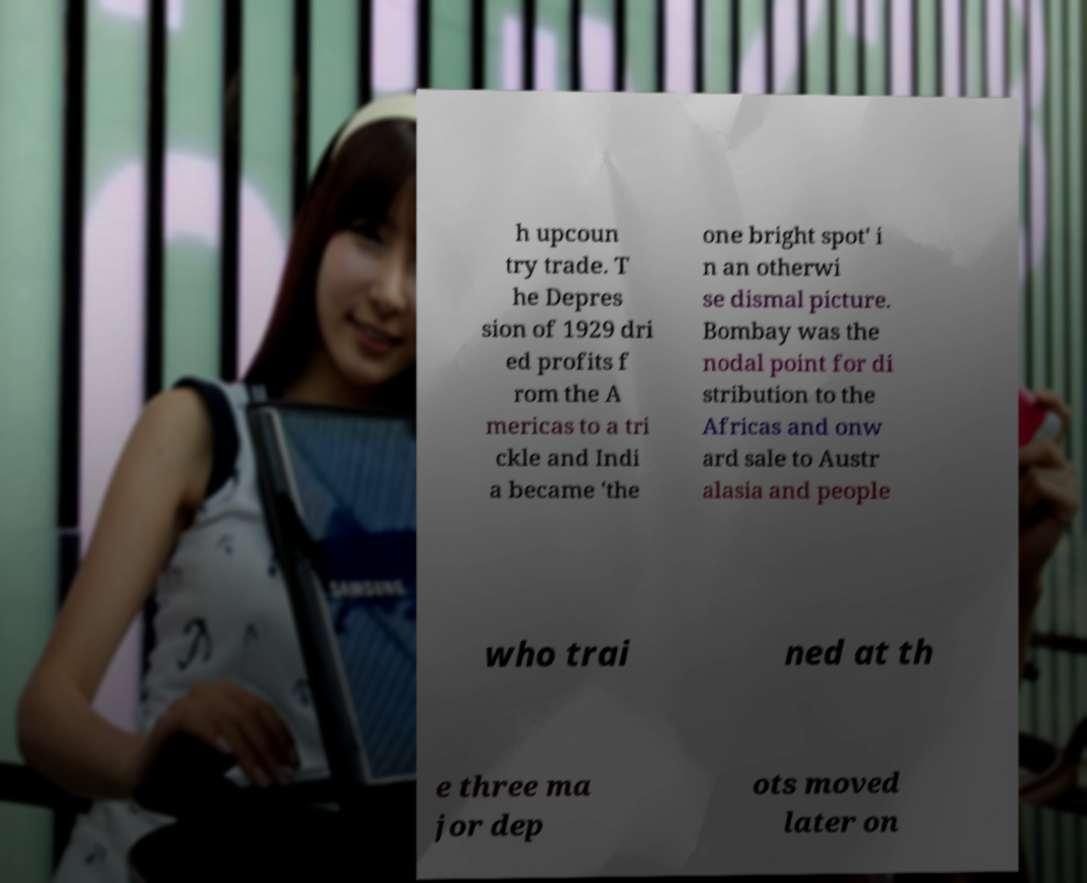There's text embedded in this image that I need extracted. Can you transcribe it verbatim? h upcoun try trade. T he Depres sion of 1929 dri ed profits f rom the A mericas to a tri ckle and Indi a became 'the one bright spot' i n an otherwi se dismal picture. Bombay was the nodal point for di stribution to the Africas and onw ard sale to Austr alasia and people who trai ned at th e three ma jor dep ots moved later on 